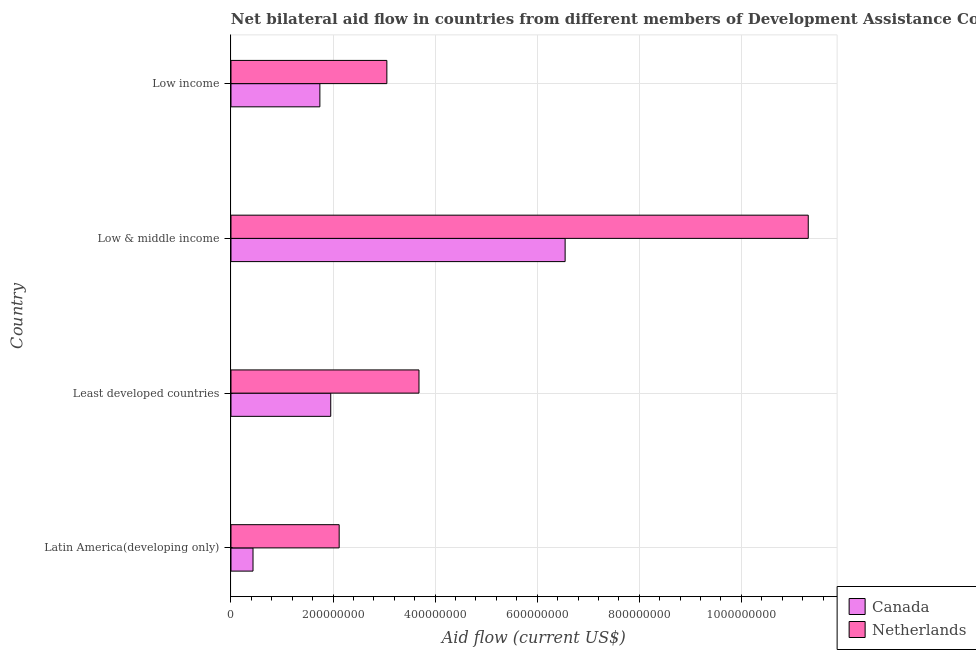Are the number of bars on each tick of the Y-axis equal?
Offer a very short reply. Yes. How many bars are there on the 3rd tick from the bottom?
Your answer should be very brief. 2. What is the label of the 3rd group of bars from the top?
Your answer should be very brief. Least developed countries. What is the amount of aid given by canada in Low income?
Make the answer very short. 1.74e+08. Across all countries, what is the maximum amount of aid given by netherlands?
Offer a very short reply. 1.13e+09. Across all countries, what is the minimum amount of aid given by canada?
Your response must be concise. 4.32e+07. In which country was the amount of aid given by netherlands maximum?
Make the answer very short. Low & middle income. In which country was the amount of aid given by netherlands minimum?
Your response must be concise. Latin America(developing only). What is the total amount of aid given by canada in the graph?
Offer a terse response. 1.07e+09. What is the difference between the amount of aid given by netherlands in Latin America(developing only) and that in Least developed countries?
Offer a terse response. -1.56e+08. What is the difference between the amount of aid given by netherlands in Least developed countries and the amount of aid given by canada in Latin America(developing only)?
Provide a succinct answer. 3.25e+08. What is the average amount of aid given by canada per country?
Make the answer very short. 2.67e+08. What is the difference between the amount of aid given by netherlands and amount of aid given by canada in Least developed countries?
Provide a short and direct response. 1.73e+08. In how many countries, is the amount of aid given by netherlands greater than 920000000 US$?
Give a very brief answer. 1. What is the ratio of the amount of aid given by netherlands in Low & middle income to that in Low income?
Provide a short and direct response. 3.7. Is the amount of aid given by canada in Least developed countries less than that in Low & middle income?
Offer a terse response. Yes. What is the difference between the highest and the second highest amount of aid given by canada?
Give a very brief answer. 4.59e+08. What is the difference between the highest and the lowest amount of aid given by canada?
Your response must be concise. 6.12e+08. What does the 2nd bar from the bottom in Latin America(developing only) represents?
Your answer should be very brief. Netherlands. How many countries are there in the graph?
Keep it short and to the point. 4. Does the graph contain grids?
Make the answer very short. Yes. Where does the legend appear in the graph?
Offer a very short reply. Bottom right. How many legend labels are there?
Offer a very short reply. 2. What is the title of the graph?
Offer a very short reply. Net bilateral aid flow in countries from different members of Development Assistance Committee. Does "Electricity and heat production" appear as one of the legend labels in the graph?
Give a very brief answer. No. What is the label or title of the Y-axis?
Provide a succinct answer. Country. What is the Aid flow (current US$) of Canada in Latin America(developing only)?
Make the answer very short. 4.32e+07. What is the Aid flow (current US$) in Netherlands in Latin America(developing only)?
Your answer should be very brief. 2.12e+08. What is the Aid flow (current US$) in Canada in Least developed countries?
Ensure brevity in your answer.  1.95e+08. What is the Aid flow (current US$) of Netherlands in Least developed countries?
Your answer should be compact. 3.68e+08. What is the Aid flow (current US$) of Canada in Low & middle income?
Your response must be concise. 6.55e+08. What is the Aid flow (current US$) in Netherlands in Low & middle income?
Offer a terse response. 1.13e+09. What is the Aid flow (current US$) in Canada in Low income?
Provide a succinct answer. 1.74e+08. What is the Aid flow (current US$) of Netherlands in Low income?
Ensure brevity in your answer.  3.05e+08. Across all countries, what is the maximum Aid flow (current US$) of Canada?
Give a very brief answer. 6.55e+08. Across all countries, what is the maximum Aid flow (current US$) of Netherlands?
Your answer should be compact. 1.13e+09. Across all countries, what is the minimum Aid flow (current US$) in Canada?
Provide a succinct answer. 4.32e+07. Across all countries, what is the minimum Aid flow (current US$) in Netherlands?
Provide a short and direct response. 2.12e+08. What is the total Aid flow (current US$) of Canada in the graph?
Your answer should be very brief. 1.07e+09. What is the total Aid flow (current US$) of Netherlands in the graph?
Your answer should be compact. 2.02e+09. What is the difference between the Aid flow (current US$) of Canada in Latin America(developing only) and that in Least developed countries?
Your answer should be very brief. -1.52e+08. What is the difference between the Aid flow (current US$) of Netherlands in Latin America(developing only) and that in Least developed countries?
Your answer should be very brief. -1.56e+08. What is the difference between the Aid flow (current US$) in Canada in Latin America(developing only) and that in Low & middle income?
Your answer should be compact. -6.12e+08. What is the difference between the Aid flow (current US$) of Netherlands in Latin America(developing only) and that in Low & middle income?
Offer a terse response. -9.19e+08. What is the difference between the Aid flow (current US$) in Canada in Latin America(developing only) and that in Low income?
Make the answer very short. -1.31e+08. What is the difference between the Aid flow (current US$) of Netherlands in Latin America(developing only) and that in Low income?
Provide a succinct answer. -9.34e+07. What is the difference between the Aid flow (current US$) in Canada in Least developed countries and that in Low & middle income?
Your answer should be very brief. -4.59e+08. What is the difference between the Aid flow (current US$) in Netherlands in Least developed countries and that in Low & middle income?
Your answer should be very brief. -7.63e+08. What is the difference between the Aid flow (current US$) in Canada in Least developed countries and that in Low income?
Give a very brief answer. 2.13e+07. What is the difference between the Aid flow (current US$) in Netherlands in Least developed countries and that in Low income?
Provide a succinct answer. 6.29e+07. What is the difference between the Aid flow (current US$) of Canada in Low & middle income and that in Low income?
Ensure brevity in your answer.  4.81e+08. What is the difference between the Aid flow (current US$) of Netherlands in Low & middle income and that in Low income?
Make the answer very short. 8.26e+08. What is the difference between the Aid flow (current US$) in Canada in Latin America(developing only) and the Aid flow (current US$) in Netherlands in Least developed countries?
Give a very brief answer. -3.25e+08. What is the difference between the Aid flow (current US$) in Canada in Latin America(developing only) and the Aid flow (current US$) in Netherlands in Low & middle income?
Keep it short and to the point. -1.09e+09. What is the difference between the Aid flow (current US$) in Canada in Latin America(developing only) and the Aid flow (current US$) in Netherlands in Low income?
Make the answer very short. -2.62e+08. What is the difference between the Aid flow (current US$) of Canada in Least developed countries and the Aid flow (current US$) of Netherlands in Low & middle income?
Provide a succinct answer. -9.36e+08. What is the difference between the Aid flow (current US$) in Canada in Least developed countries and the Aid flow (current US$) in Netherlands in Low income?
Your answer should be very brief. -1.10e+08. What is the difference between the Aid flow (current US$) in Canada in Low & middle income and the Aid flow (current US$) in Netherlands in Low income?
Your answer should be very brief. 3.49e+08. What is the average Aid flow (current US$) in Canada per country?
Offer a very short reply. 2.67e+08. What is the average Aid flow (current US$) of Netherlands per country?
Make the answer very short. 5.04e+08. What is the difference between the Aid flow (current US$) in Canada and Aid flow (current US$) in Netherlands in Latin America(developing only)?
Offer a very short reply. -1.69e+08. What is the difference between the Aid flow (current US$) of Canada and Aid flow (current US$) of Netherlands in Least developed countries?
Keep it short and to the point. -1.73e+08. What is the difference between the Aid flow (current US$) of Canada and Aid flow (current US$) of Netherlands in Low & middle income?
Your answer should be compact. -4.76e+08. What is the difference between the Aid flow (current US$) in Canada and Aid flow (current US$) in Netherlands in Low income?
Your answer should be very brief. -1.31e+08. What is the ratio of the Aid flow (current US$) of Canada in Latin America(developing only) to that in Least developed countries?
Offer a very short reply. 0.22. What is the ratio of the Aid flow (current US$) in Netherlands in Latin America(developing only) to that in Least developed countries?
Keep it short and to the point. 0.58. What is the ratio of the Aid flow (current US$) of Canada in Latin America(developing only) to that in Low & middle income?
Keep it short and to the point. 0.07. What is the ratio of the Aid flow (current US$) in Netherlands in Latin America(developing only) to that in Low & middle income?
Offer a terse response. 0.19. What is the ratio of the Aid flow (current US$) in Canada in Latin America(developing only) to that in Low income?
Give a very brief answer. 0.25. What is the ratio of the Aid flow (current US$) of Netherlands in Latin America(developing only) to that in Low income?
Your answer should be very brief. 0.69. What is the ratio of the Aid flow (current US$) of Canada in Least developed countries to that in Low & middle income?
Make the answer very short. 0.3. What is the ratio of the Aid flow (current US$) in Netherlands in Least developed countries to that in Low & middle income?
Keep it short and to the point. 0.33. What is the ratio of the Aid flow (current US$) in Canada in Least developed countries to that in Low income?
Keep it short and to the point. 1.12. What is the ratio of the Aid flow (current US$) in Netherlands in Least developed countries to that in Low income?
Ensure brevity in your answer.  1.21. What is the ratio of the Aid flow (current US$) in Canada in Low & middle income to that in Low income?
Offer a very short reply. 3.76. What is the ratio of the Aid flow (current US$) in Netherlands in Low & middle income to that in Low income?
Provide a succinct answer. 3.7. What is the difference between the highest and the second highest Aid flow (current US$) of Canada?
Provide a short and direct response. 4.59e+08. What is the difference between the highest and the second highest Aid flow (current US$) in Netherlands?
Keep it short and to the point. 7.63e+08. What is the difference between the highest and the lowest Aid flow (current US$) of Canada?
Ensure brevity in your answer.  6.12e+08. What is the difference between the highest and the lowest Aid flow (current US$) of Netherlands?
Ensure brevity in your answer.  9.19e+08. 